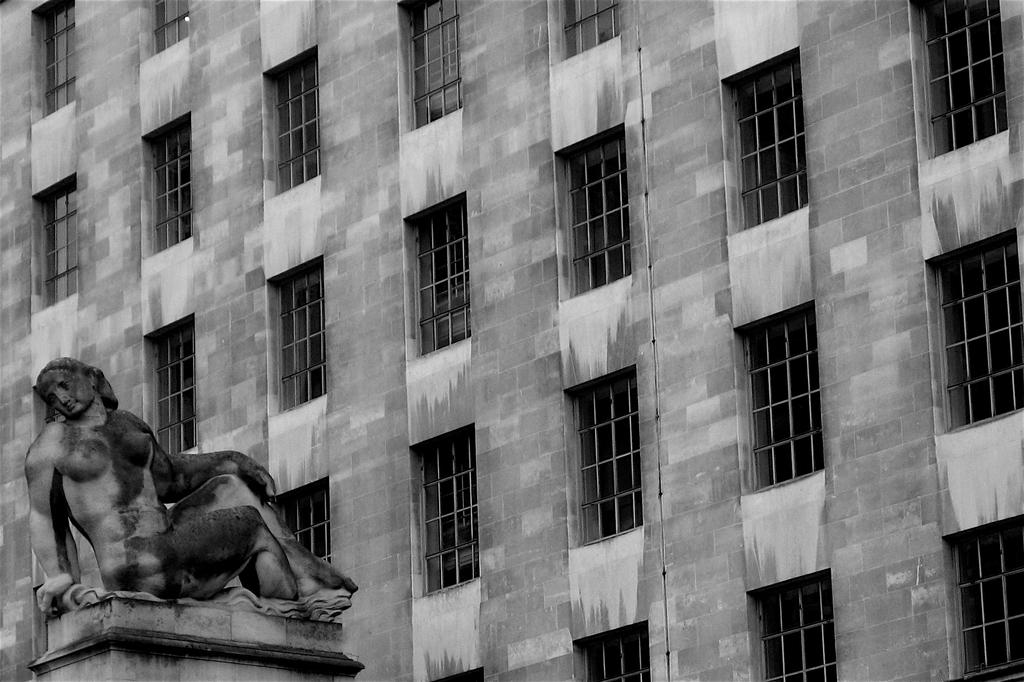What is the color scheme of the image? The image is black and white. What type of structure can be seen in the image? There is a building with windows in the image. What artistic element is present in the image? There is a sculpture in the image. Where is the sculpture located in relation to the building? The sculpture is on a pillar. What type of acoustics can be heard from the copper sculpture in the image? There is no copper sculpture present in the image, and therefore no acoustics can be heard from it. 